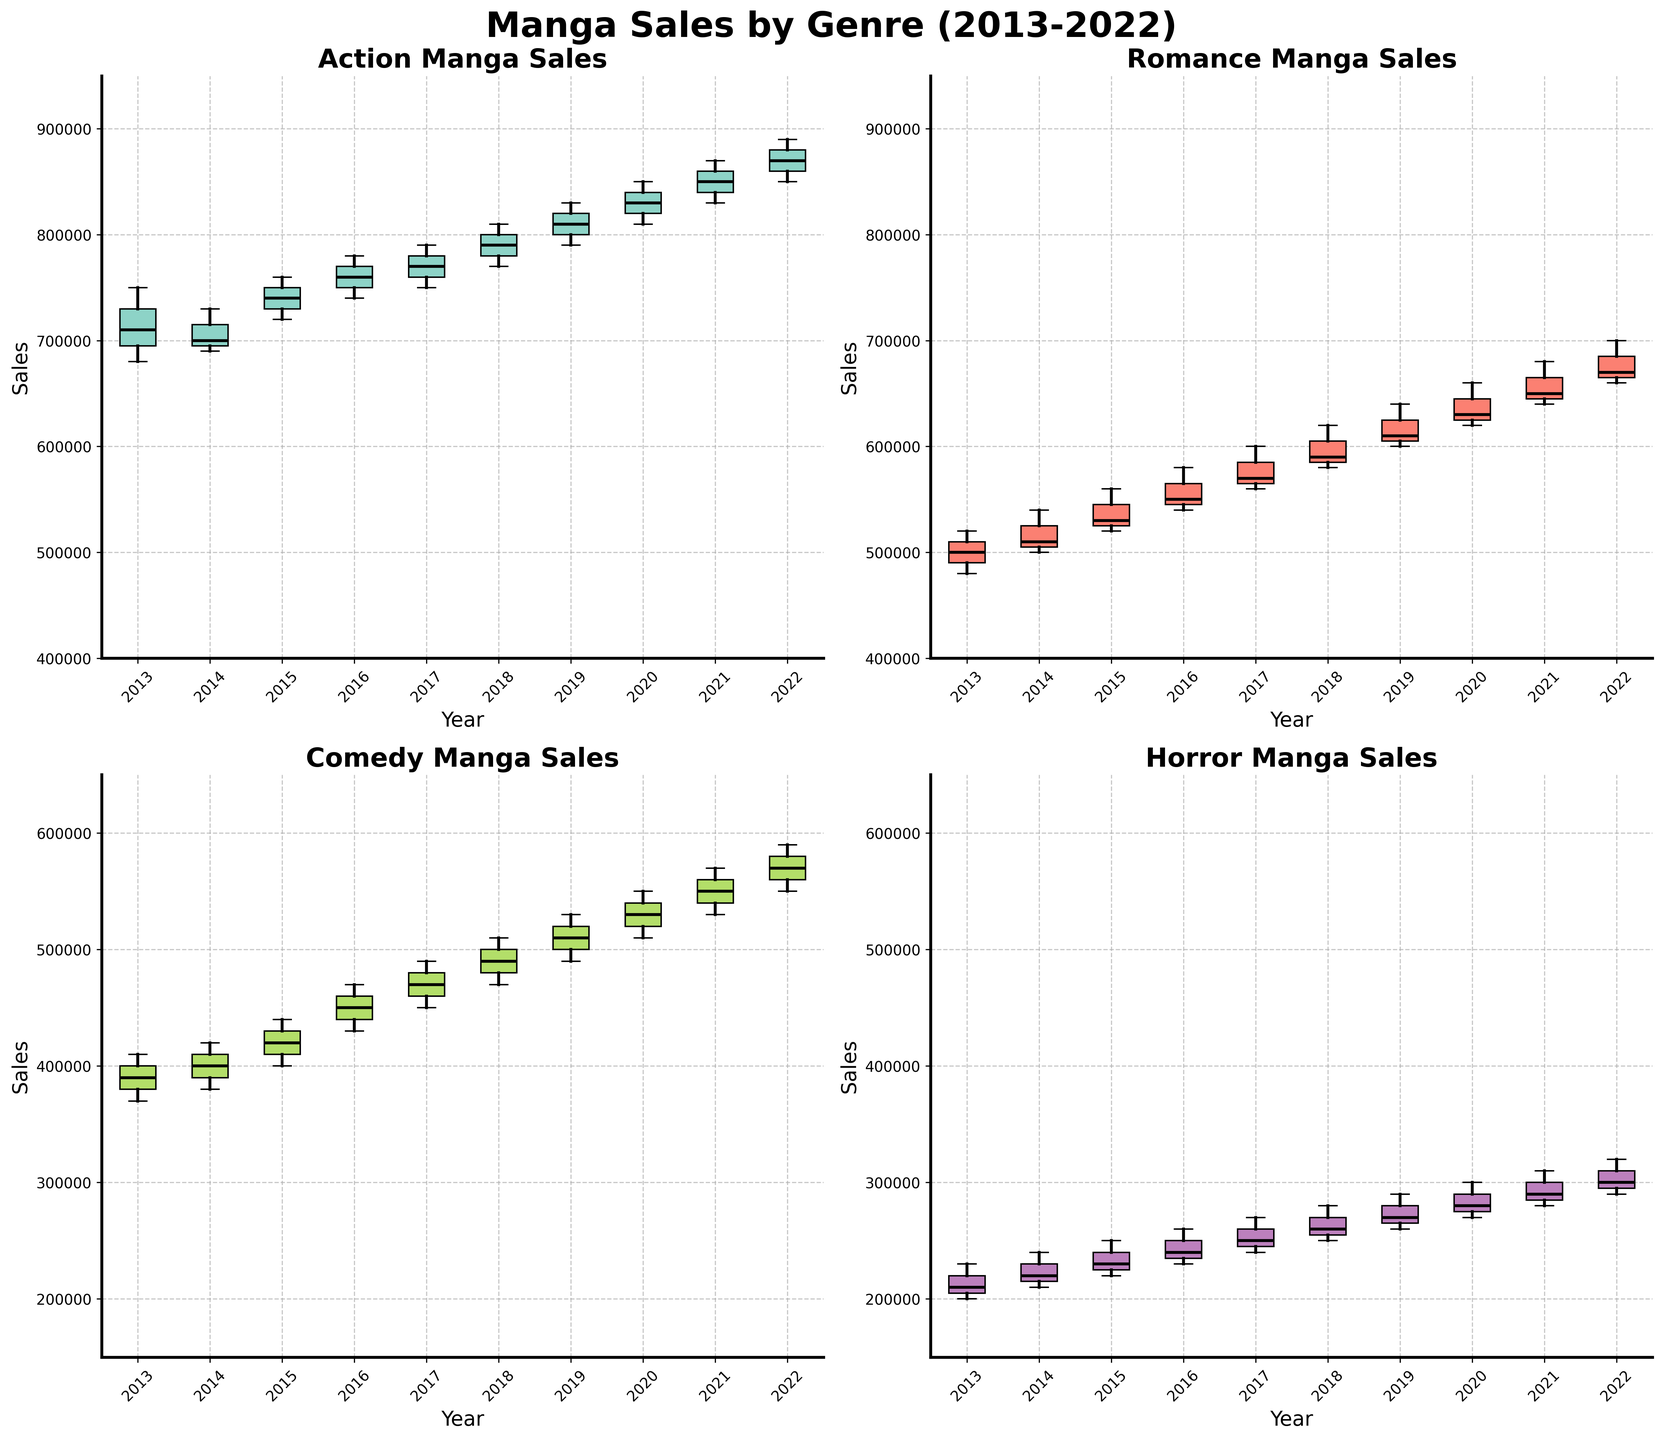What's the highest median sales value for Action Manga across all years? The median value of a box plot is marked by the line inside the box. We'd look at the Action Manga box plots across different years and find the highest median value among them. From the figure, it appears Action Manga in the year 2022 has the highest median.
Answer: 870,000 In which year did Romance Manga have the lowest median sales? Similar to the previous question, find the lowest median line inside the Romance Manga box plots across all years. 2013 shows the lowest median for Romance Manga.
Answer: 2013 How does the sales median of Comedy Manga in 2017 compare to 2022? First, locate the median line for Comedy Manga in 2017 and 2022. Then compare their heights. The median in 2022 is higher than that in 2017.
Answer: Higher What's the range of sales in Horror Manga in 2021? To find the range, subtract the lower whisker value from the upper whisker value in the 2021 Horror Manga box plot. The lower whisker is at 280,000 and the upper whisker at 310,000; thus, the range is 310,000 - 280,000.
Answer: 30,000 Considering all genres, which one shows the maximum variability in 2018? Variability in box plots can be seen from the spread of the whiskers and the box. By comparing the whiskers and boxes for all genres in 2018, Action Manga exhibits the most variability.
Answer: Action Which genre has the most consistent sales across all ten years? Consistency can be determined by the length of the box and whiskers across all years. By examining this for each genre, Comedy Manga has the most consistent sales, reflected by relatively shorter boxes and whiskers over the years.
Answer: Comedy What's the difference in the interquartile range (IQR) between 2015 and 2020 for Action Manga? IQR is the difference between the upper quartile and the lower quartile. Locate the top and bottom of the boxes for Action Manga in 2015 and 2020, subtract for each year, and then compare the two. The IQR in 2015 is smaller compared to 2020.
Answer: Smaller Are there any years where Horror Manga sales appear to have outliers? Outliers in box plots are typically shown as dots beyond the whiskers. Look for any dots outside the whiskers in the Horror Manga plots. In the provided dataset range (2013-2022), No explicit dots appear outside the whiskers indicating outliers.
Answer: No Between 2016 and 2019, by how much did the median sales of Romance Manga increase? Locate the median lines inside the boxes for 2016 and 2019 Romance Manga. Calculate the difference between the medians of these years. The median in 2016 is 540,000 and in 2019 is 600,000, so the increase is 600,000 - 540,000.
Answer: 60,000 